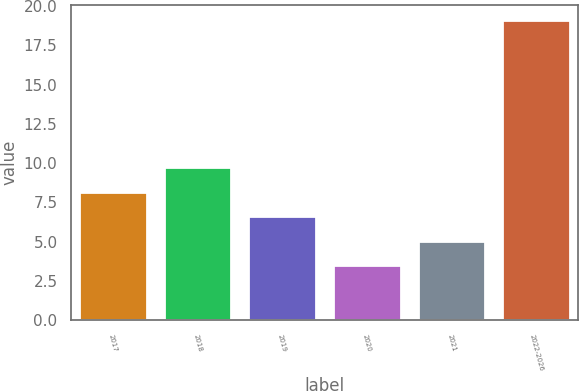<chart> <loc_0><loc_0><loc_500><loc_500><bar_chart><fcel>2017<fcel>2018<fcel>2019<fcel>2020<fcel>2021<fcel>2022-2026<nl><fcel>8.18<fcel>9.74<fcel>6.62<fcel>3.5<fcel>5.06<fcel>19.1<nl></chart> 